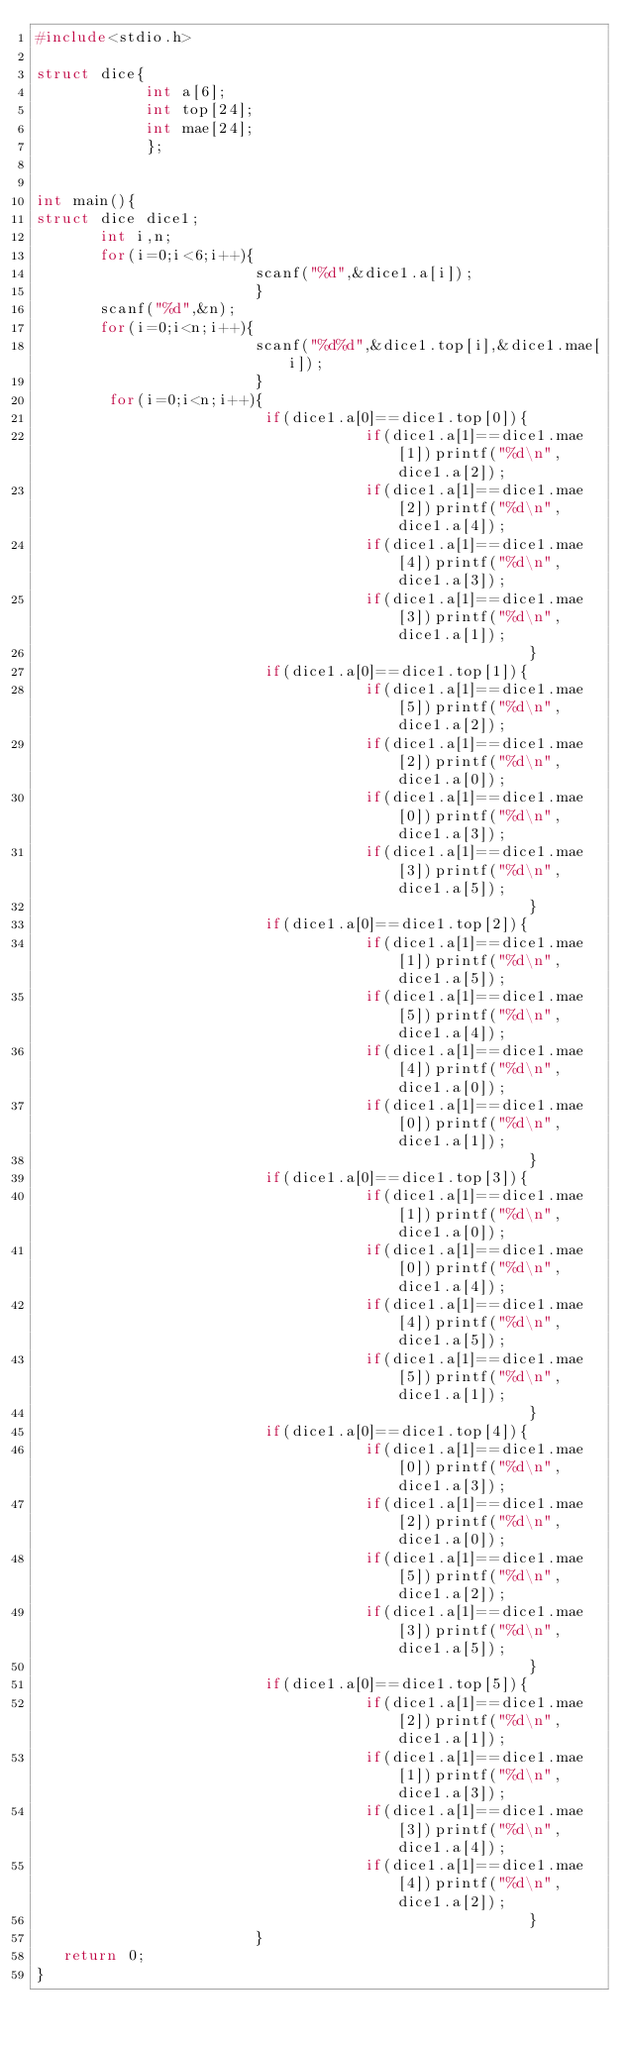<code> <loc_0><loc_0><loc_500><loc_500><_C_>#include<stdio.h>

struct dice{
            int a[6];
            int top[24];
            int mae[24];
            };


int main(){
struct dice dice1;
       int i,n;
       for(i=0;i<6;i++){
                        scanf("%d",&dice1.a[i]);
                        }
       scanf("%d",&n);
       for(i=0;i<n;i++){
                        scanf("%d%d",&dice1.top[i],&dice1.mae[i]);
                        }
        for(i=0;i<n;i++){
                         if(dice1.a[0]==dice1.top[0]){
                                    if(dice1.a[1]==dice1.mae[1])printf("%d\n",dice1.a[2]);
                                    if(dice1.a[1]==dice1.mae[2])printf("%d\n",dice1.a[4]);
                                    if(dice1.a[1]==dice1.mae[4])printf("%d\n",dice1.a[3]);
                                    if(dice1.a[1]==dice1.mae[3])printf("%d\n",dice1.a[1]);
                                                      }
                         if(dice1.a[0]==dice1.top[1]){
                                    if(dice1.a[1]==dice1.mae[5])printf("%d\n",dice1.a[2]);
                                    if(dice1.a[1]==dice1.mae[2])printf("%d\n",dice1.a[0]);
                                    if(dice1.a[1]==dice1.mae[0])printf("%d\n",dice1.a[3]);
                                    if(dice1.a[1]==dice1.mae[3])printf("%d\n",dice1.a[5]);
                                                      }
                         if(dice1.a[0]==dice1.top[2]){
                                    if(dice1.a[1]==dice1.mae[1])printf("%d\n",dice1.a[5]);
                                    if(dice1.a[1]==dice1.mae[5])printf("%d\n",dice1.a[4]);
                                    if(dice1.a[1]==dice1.mae[4])printf("%d\n",dice1.a[0]);
                                    if(dice1.a[1]==dice1.mae[0])printf("%d\n",dice1.a[1]);
                                                      }
                         if(dice1.a[0]==dice1.top[3]){
                                    if(dice1.a[1]==dice1.mae[1])printf("%d\n",dice1.a[0]);
                                    if(dice1.a[1]==dice1.mae[0])printf("%d\n",dice1.a[4]);
                                    if(dice1.a[1]==dice1.mae[4])printf("%d\n",dice1.a[5]);
                                    if(dice1.a[1]==dice1.mae[5])printf("%d\n",dice1.a[1]);
                                                      }
                         if(dice1.a[0]==dice1.top[4]){
                                    if(dice1.a[1]==dice1.mae[0])printf("%d\n",dice1.a[3]);
                                    if(dice1.a[1]==dice1.mae[2])printf("%d\n",dice1.a[0]);
                                    if(dice1.a[1]==dice1.mae[5])printf("%d\n",dice1.a[2]);
                                    if(dice1.a[1]==dice1.mae[3])printf("%d\n",dice1.a[5]);
                                                      }
                         if(dice1.a[0]==dice1.top[5]){
                                    if(dice1.a[1]==dice1.mae[2])printf("%d\n",dice1.a[1]);
                                    if(dice1.a[1]==dice1.mae[1])printf("%d\n",dice1.a[3]);
                                    if(dice1.a[1]==dice1.mae[3])printf("%d\n",dice1.a[4]);
                                    if(dice1.a[1]==dice1.mae[4])printf("%d\n",dice1.a[2]);
                                                      }
                        }
   return 0;
}

</code> 